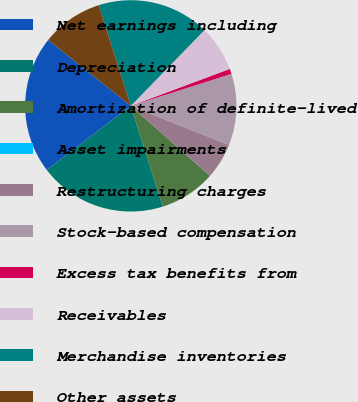Convert chart to OTSL. <chart><loc_0><loc_0><loc_500><loc_500><pie_chart><fcel>Net earnings including<fcel>Depreciation<fcel>Amortization of definite-lived<fcel>Asset impairments<fcel>Restructuring charges<fcel>Stock-based compensation<fcel>Excess tax benefits from<fcel>Receivables<fcel>Merchandise inventories<fcel>Other assets<nl><fcel>21.09%<fcel>19.53%<fcel>8.59%<fcel>0.01%<fcel>5.47%<fcel>10.94%<fcel>0.79%<fcel>7.03%<fcel>17.18%<fcel>9.38%<nl></chart> 